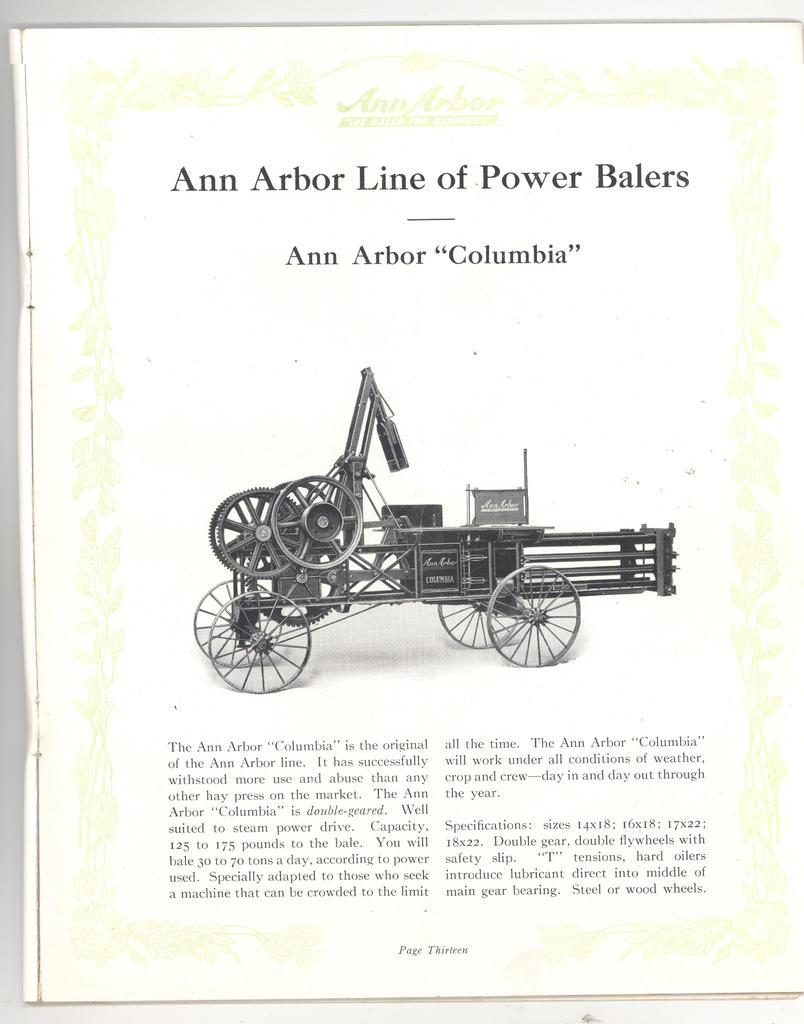What is the primary object featured in the image? The main highlight of the image is a wagon. What is written on the paper in the image? There is writing on the paper using black letters. Can you describe the paper in the image? The paper is the secondary object in the image, with writing on it. What type of humor can be seen in the image? There is no humor present in the image; it features a wagon and a paper with writing on it. Can you tell me how many carpenters are working near the lake in the image? There is no lake or carpenters present in the image. 